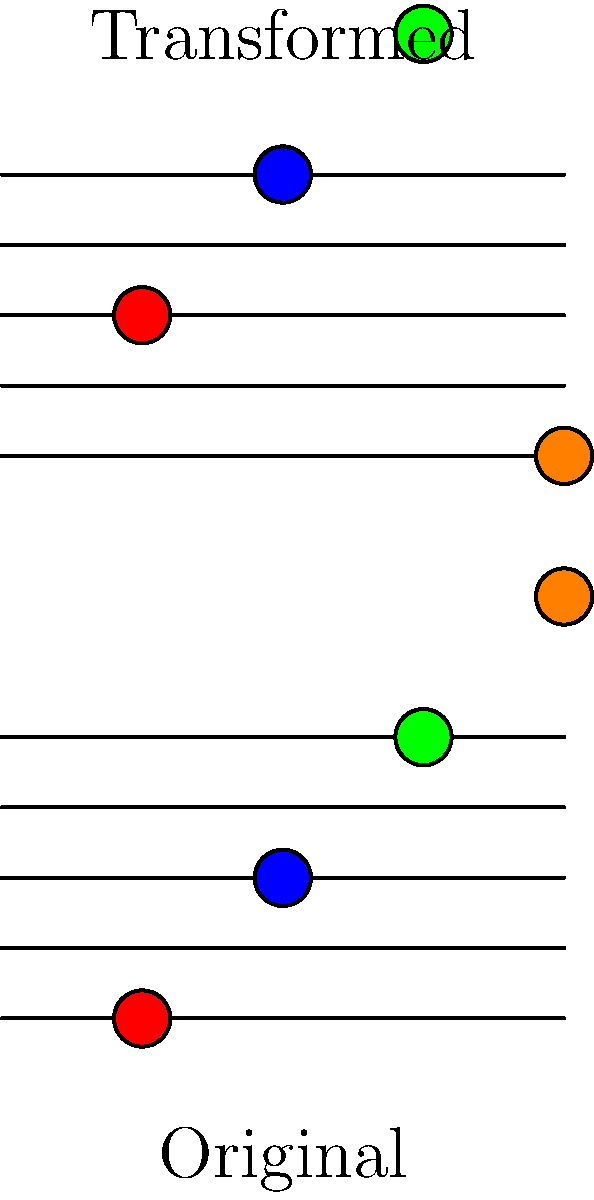Consider a group $G$ of musical transformations on a four-note melody. The image shows the original melody (bottom staff) and a transformed version (top staff). If the transformation $T$ that maps the original to the transformed melody generates a normal subgroup $H$ of $G$, what is the order of the quotient group $G/H$? Let's approach this step-by-step:

1) First, observe the transformation $T$:
   - Each note is moved up one position on the staff.
   - The colors (representing pitch or timbre) remain unchanged.
   - The top note wraps around to the bottom.

2) This transformation is a cyclic permutation of order 4. Let's call it $T = (1234)$ in cycle notation.

3) The subgroup $H$ generated by $T$ is $H = \{e, T, T^2, T^3\}$, where $e$ is the identity transformation.

4) For $H$ to be normal in $G$, we must have $gHg^{-1} = H$ for all $g \in G$. This is true because cyclic subgroups are always normal in abelian groups, and permutation groups on 4 elements are abelian.

5) The quotient group $G/H$ consists of cosets of $H$ in $G$. Each coset represents a distinct "type" of transformation that can't be achieved by repeatedly applying $T$.

6) The order of $G/H$ is equal to the index of $H$ in $G$: $|G/H| = [G:H] = |G|/|H|$

7) We don't know the full order of $G$, but we know it must be a multiple of $|H| = 4$.

8) The smallest possible order for $G/H$ is when $G = H$, which gives $|G/H| = 1$.

9) The next possible order would be when $G$ includes an additional transformation not in $H$, making $|G| = 8$ and $|G/H| = 2$.

10) Given the musical context and the fact that we're dealing with a four-note melody, it's most likely that $G$ represents all possible permutations of the four notes, making $|G| = 4! = 24$.

11) In this case, $|G/H| = 24/4 = 6$.

Therefore, the most musically relevant answer is that the order of $G/H$ is 6.
Answer: 6 